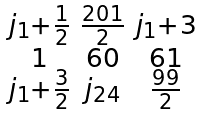<formula> <loc_0><loc_0><loc_500><loc_500>\begin{smallmatrix} j _ { 1 } + \frac { 1 } 2 & \frac { 2 0 1 } 2 & j _ { 1 } + 3 \\ 1 & 6 0 & 6 1 \\ j _ { 1 } + \frac { 3 } { 2 } & j _ { 2 4 } & \frac { 9 9 } 2 \end{smallmatrix}</formula> 